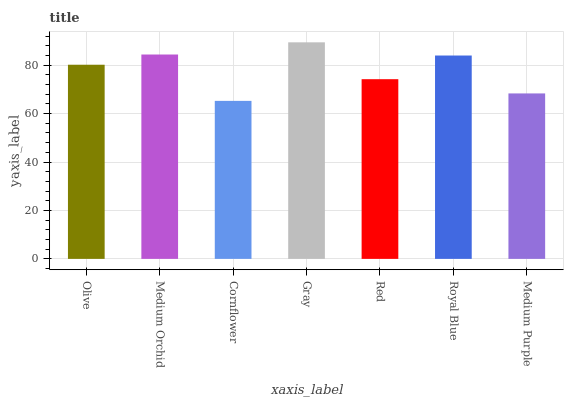Is Medium Orchid the minimum?
Answer yes or no. No. Is Medium Orchid the maximum?
Answer yes or no. No. Is Medium Orchid greater than Olive?
Answer yes or no. Yes. Is Olive less than Medium Orchid?
Answer yes or no. Yes. Is Olive greater than Medium Orchid?
Answer yes or no. No. Is Medium Orchid less than Olive?
Answer yes or no. No. Is Olive the high median?
Answer yes or no. Yes. Is Olive the low median?
Answer yes or no. Yes. Is Medium Purple the high median?
Answer yes or no. No. Is Medium Purple the low median?
Answer yes or no. No. 